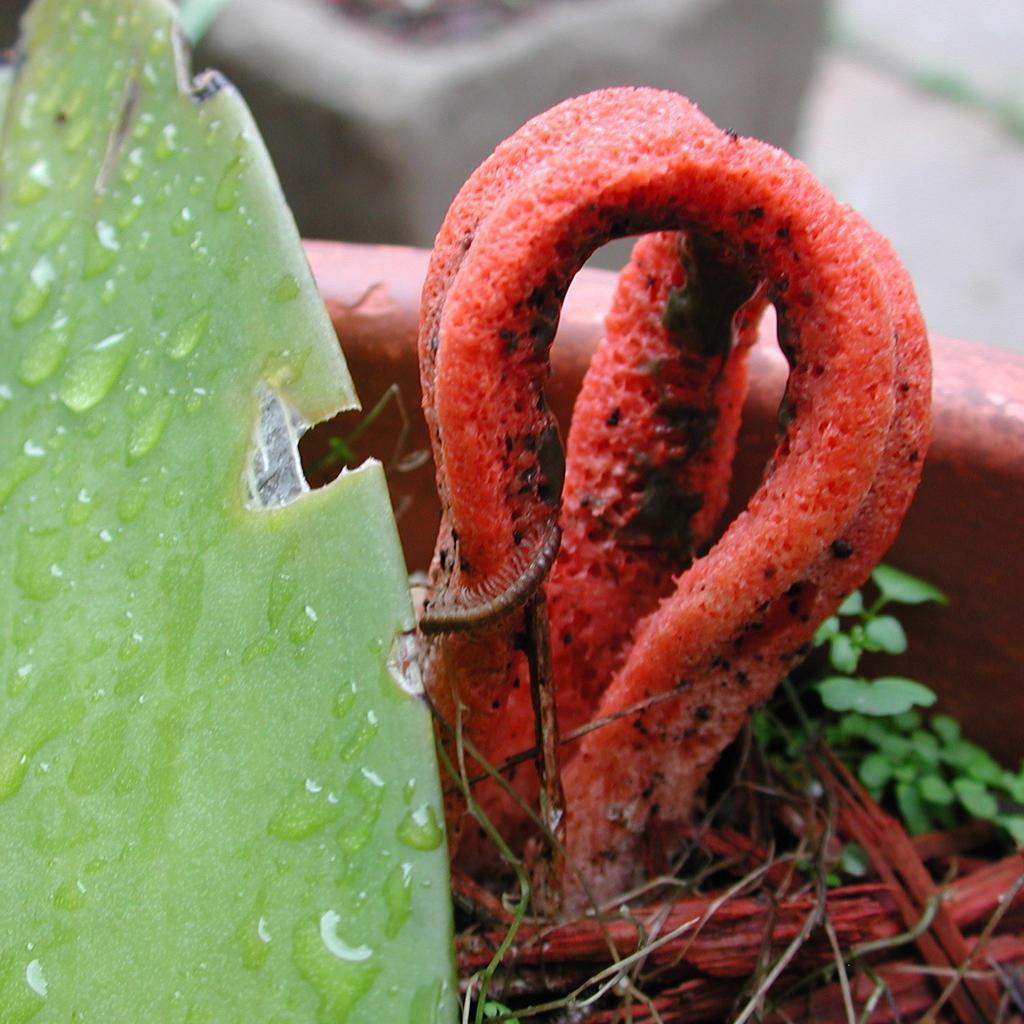Describe this image in one or two sentences. This picture shows a leaf with water droplets on it and we see a caterpillar on the plant in the pot. 